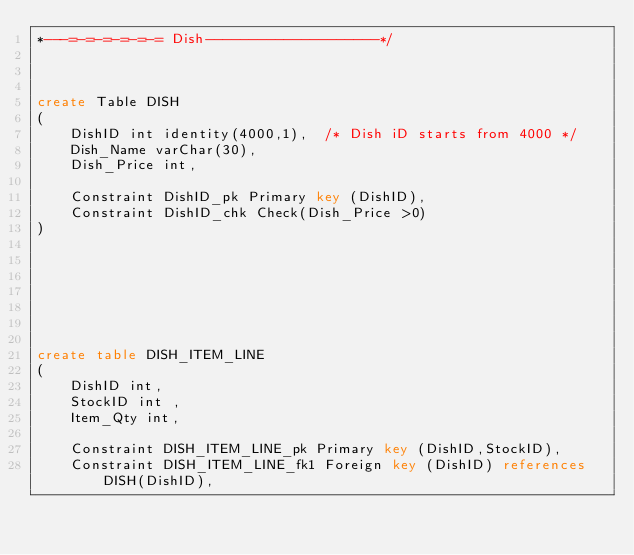<code> <loc_0><loc_0><loc_500><loc_500><_SQL_>*---=-=-=-=-=-= Dish--------------------*/



create Table DISH
(
	DishID int identity(4000,1),  /* Dish iD starts from 4000 */
	Dish_Name varChar(30), 
	Dish_Price int,

	Constraint DishID_pk Primary key (DishID),
	Constraint DishID_chk Check(Dish_Price >0)
)







create table DISH_ITEM_LINE
(
	DishID int,
	StockID int	,
	Item_Qty int,
	
	Constraint DISH_ITEM_LINE_pk Primary key (DishID,StockID),
	Constraint DISH_ITEM_LINE_fk1 Foreign key (DishID) references DISH(DishID),</code> 